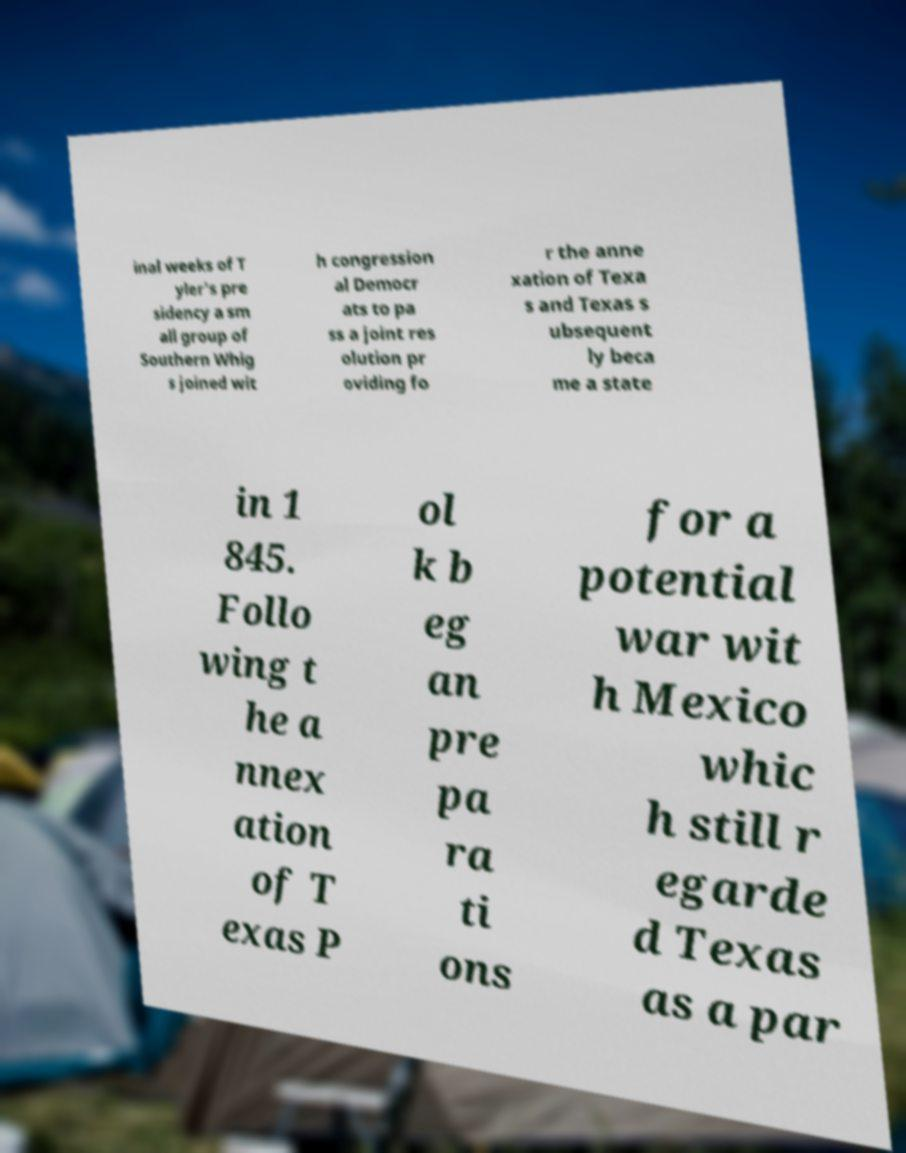Could you assist in decoding the text presented in this image and type it out clearly? inal weeks of T yler's pre sidency a sm all group of Southern Whig s joined wit h congression al Democr ats to pa ss a joint res olution pr oviding fo r the anne xation of Texa s and Texas s ubsequent ly beca me a state in 1 845. Follo wing t he a nnex ation of T exas P ol k b eg an pre pa ra ti ons for a potential war wit h Mexico whic h still r egarde d Texas as a par 